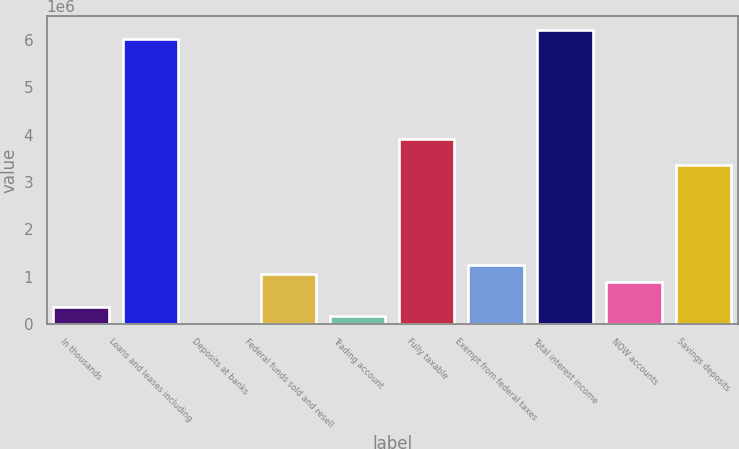Convert chart to OTSL. <chart><loc_0><loc_0><loc_500><loc_500><bar_chart><fcel>In thousands<fcel>Loans and leases including<fcel>Deposits at banks<fcel>Federal funds sold and resell<fcel>Trading account<fcel>Fully taxable<fcel>Exempt from federal taxes<fcel>Total interest income<fcel>NOW accounts<fcel>Savings deposits<nl><fcel>354803<fcel>6.02673e+06<fcel>308<fcel>1.06379e+06<fcel>177556<fcel>3.89976e+06<fcel>1.24104e+06<fcel>6.20397e+06<fcel>886546<fcel>3.36801e+06<nl></chart> 